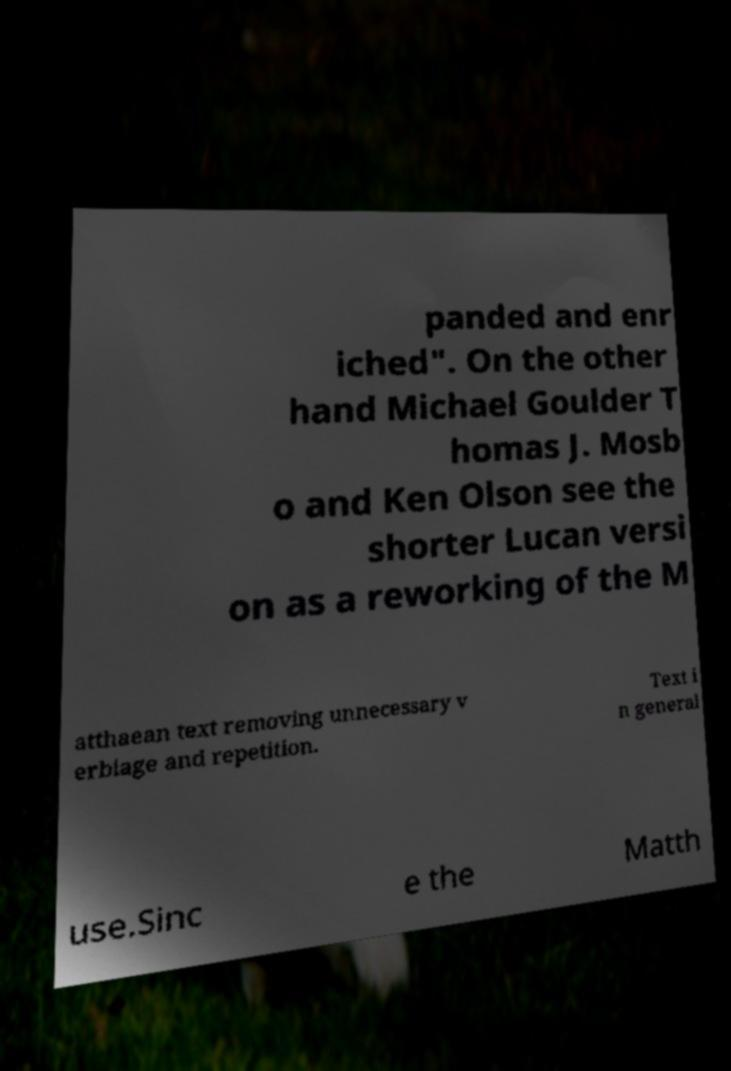Could you assist in decoding the text presented in this image and type it out clearly? panded and enr iched". On the other hand Michael Goulder T homas J. Mosb o and Ken Olson see the shorter Lucan versi on as a reworking of the M atthaean text removing unnecessary v erbiage and repetition. Text i n general use.Sinc e the Matth 